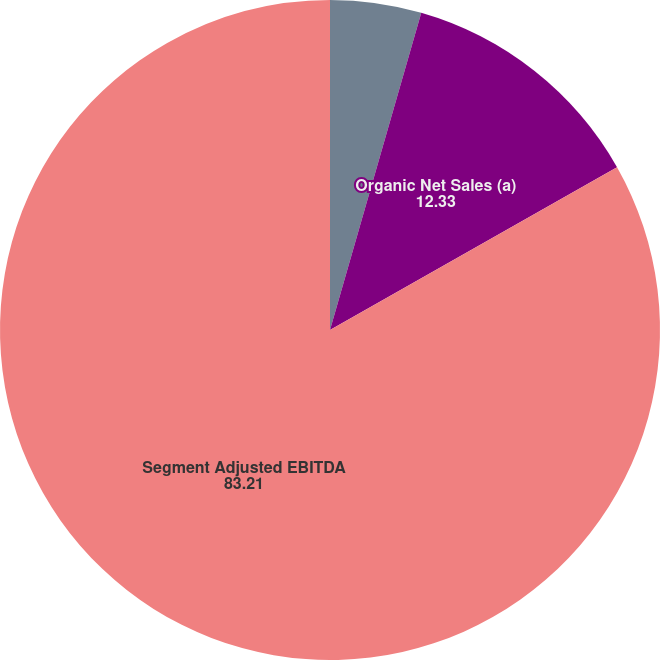Convert chart to OTSL. <chart><loc_0><loc_0><loc_500><loc_500><pie_chart><fcel>Net sales<fcel>Organic Net Sales (a)<fcel>Segment Adjusted EBITDA<nl><fcel>4.46%<fcel>12.33%<fcel>83.21%<nl></chart> 